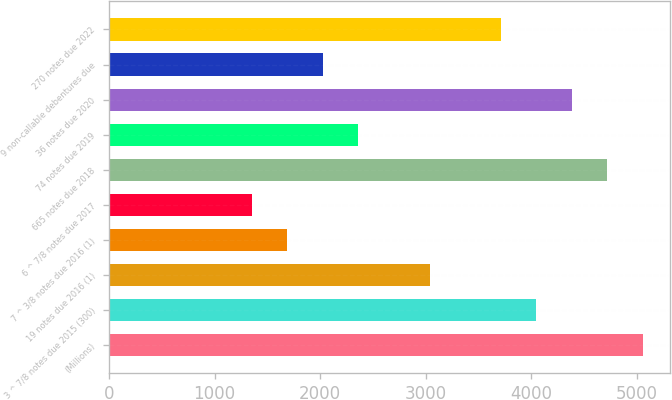Convert chart to OTSL. <chart><loc_0><loc_0><loc_500><loc_500><bar_chart><fcel>(Millions)<fcel>3 ^ 7/8 notes due 2015 (300)<fcel>19 notes due 2016 (1)<fcel>7 ^ 3/8 notes due 2016 (1)<fcel>6 ^ 7/8 notes due 2017<fcel>665 notes due 2018<fcel>74 notes due 2019<fcel>36 notes due 2020<fcel>9 non-callable debentures due<fcel>270 notes due 2022<nl><fcel>5062<fcel>4050.4<fcel>3038.8<fcel>1690<fcel>1352.8<fcel>4724.8<fcel>2364.4<fcel>4387.6<fcel>2027.2<fcel>3713.2<nl></chart> 